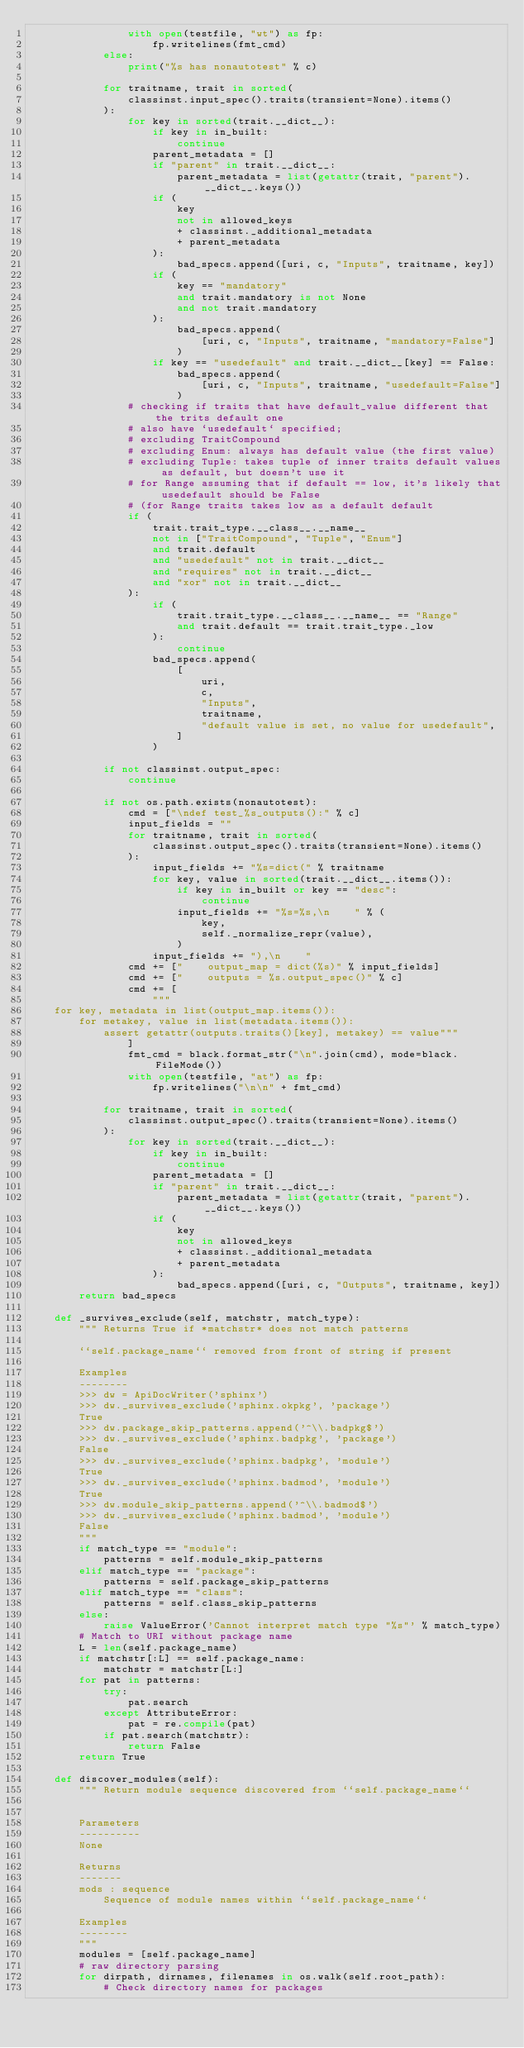<code> <loc_0><loc_0><loc_500><loc_500><_Python_>                with open(testfile, "wt") as fp:
                    fp.writelines(fmt_cmd)
            else:
                print("%s has nonautotest" % c)

            for traitname, trait in sorted(
                classinst.input_spec().traits(transient=None).items()
            ):
                for key in sorted(trait.__dict__):
                    if key in in_built:
                        continue
                    parent_metadata = []
                    if "parent" in trait.__dict__:
                        parent_metadata = list(getattr(trait, "parent").__dict__.keys())
                    if (
                        key
                        not in allowed_keys
                        + classinst._additional_metadata
                        + parent_metadata
                    ):
                        bad_specs.append([uri, c, "Inputs", traitname, key])
                    if (
                        key == "mandatory"
                        and trait.mandatory is not None
                        and not trait.mandatory
                    ):
                        bad_specs.append(
                            [uri, c, "Inputs", traitname, "mandatory=False"]
                        )
                    if key == "usedefault" and trait.__dict__[key] == False:
                        bad_specs.append(
                            [uri, c, "Inputs", traitname, "usedefault=False"]
                        )
                # checking if traits that have default_value different that the trits default one
                # also have `usedefault` specified;
                # excluding TraitCompound
                # excluding Enum: always has default value (the first value)
                # excluding Tuple: takes tuple of inner traits default values as default, but doesn't use it
                # for Range assuming that if default == low, it's likely that usedefault should be False
                # (for Range traits takes low as a default default
                if (
                    trait.trait_type.__class__.__name__
                    not in ["TraitCompound", "Tuple", "Enum"]
                    and trait.default
                    and "usedefault" not in trait.__dict__
                    and "requires" not in trait.__dict__
                    and "xor" not in trait.__dict__
                ):
                    if (
                        trait.trait_type.__class__.__name__ == "Range"
                        and trait.default == trait.trait_type._low
                    ):
                        continue
                    bad_specs.append(
                        [
                            uri,
                            c,
                            "Inputs",
                            traitname,
                            "default value is set, no value for usedefault",
                        ]
                    )

            if not classinst.output_spec:
                continue

            if not os.path.exists(nonautotest):
                cmd = ["\ndef test_%s_outputs():" % c]
                input_fields = ""
                for traitname, trait in sorted(
                    classinst.output_spec().traits(transient=None).items()
                ):
                    input_fields += "%s=dict(" % traitname
                    for key, value in sorted(trait.__dict__.items()):
                        if key in in_built or key == "desc":
                            continue
                        input_fields += "%s=%s,\n    " % (
                            key,
                            self._normalize_repr(value),
                        )
                    input_fields += "),\n    "
                cmd += ["    output_map = dict(%s)" % input_fields]
                cmd += ["    outputs = %s.output_spec()" % c]
                cmd += [
                    """
    for key, metadata in list(output_map.items()):
        for metakey, value in list(metadata.items()):
            assert getattr(outputs.traits()[key], metakey) == value"""
                ]
                fmt_cmd = black.format_str("\n".join(cmd), mode=black.FileMode())
                with open(testfile, "at") as fp:
                    fp.writelines("\n\n" + fmt_cmd)

            for traitname, trait in sorted(
                classinst.output_spec().traits(transient=None).items()
            ):
                for key in sorted(trait.__dict__):
                    if key in in_built:
                        continue
                    parent_metadata = []
                    if "parent" in trait.__dict__:
                        parent_metadata = list(getattr(trait, "parent").__dict__.keys())
                    if (
                        key
                        not in allowed_keys
                        + classinst._additional_metadata
                        + parent_metadata
                    ):
                        bad_specs.append([uri, c, "Outputs", traitname, key])
        return bad_specs

    def _survives_exclude(self, matchstr, match_type):
        """ Returns True if *matchstr* does not match patterns

        ``self.package_name`` removed from front of string if present

        Examples
        --------
        >>> dw = ApiDocWriter('sphinx')
        >>> dw._survives_exclude('sphinx.okpkg', 'package')
        True
        >>> dw.package_skip_patterns.append('^\\.badpkg$')
        >>> dw._survives_exclude('sphinx.badpkg', 'package')
        False
        >>> dw._survives_exclude('sphinx.badpkg', 'module')
        True
        >>> dw._survives_exclude('sphinx.badmod', 'module')
        True
        >>> dw.module_skip_patterns.append('^\\.badmod$')
        >>> dw._survives_exclude('sphinx.badmod', 'module')
        False
        """
        if match_type == "module":
            patterns = self.module_skip_patterns
        elif match_type == "package":
            patterns = self.package_skip_patterns
        elif match_type == "class":
            patterns = self.class_skip_patterns
        else:
            raise ValueError('Cannot interpret match type "%s"' % match_type)
        # Match to URI without package name
        L = len(self.package_name)
        if matchstr[:L] == self.package_name:
            matchstr = matchstr[L:]
        for pat in patterns:
            try:
                pat.search
            except AttributeError:
                pat = re.compile(pat)
            if pat.search(matchstr):
                return False
        return True

    def discover_modules(self):
        """ Return module sequence discovered from ``self.package_name``


        Parameters
        ----------
        None

        Returns
        -------
        mods : sequence
            Sequence of module names within ``self.package_name``

        Examples
        --------
        """
        modules = [self.package_name]
        # raw directory parsing
        for dirpath, dirnames, filenames in os.walk(self.root_path):
            # Check directory names for packages</code> 